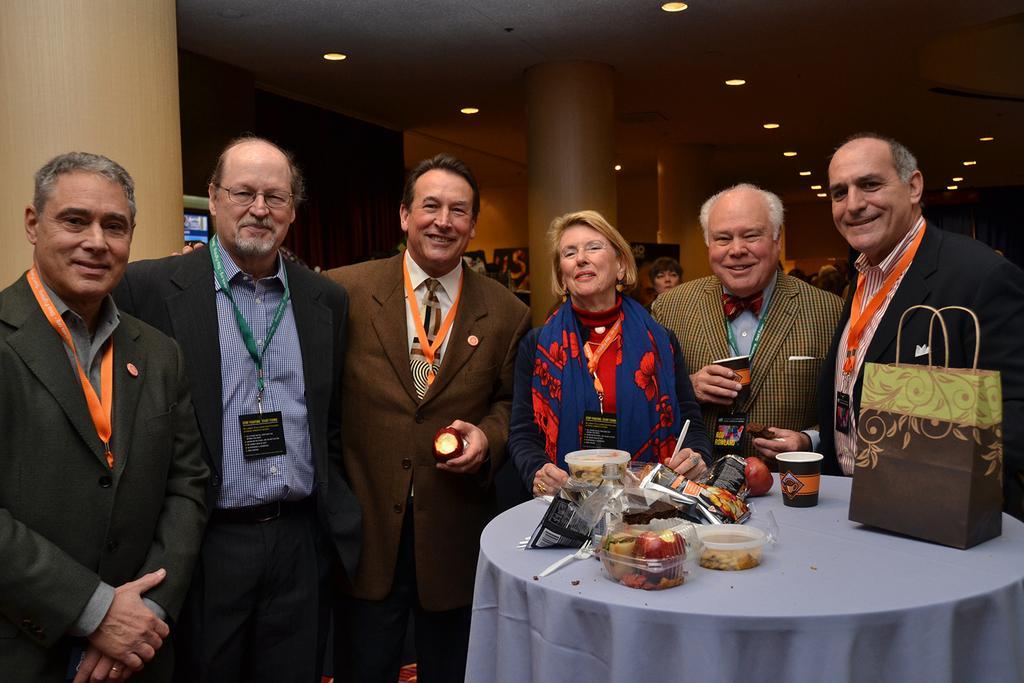Can you describe this image briefly? These persons are standing and wear tags and smiling,this person holding apple and this person holding cup. We can see bag,boxes,fruits,cup,packets,fork on the table. On the background we can see wall,pillar,persons,banner. On the top we can see lights. 